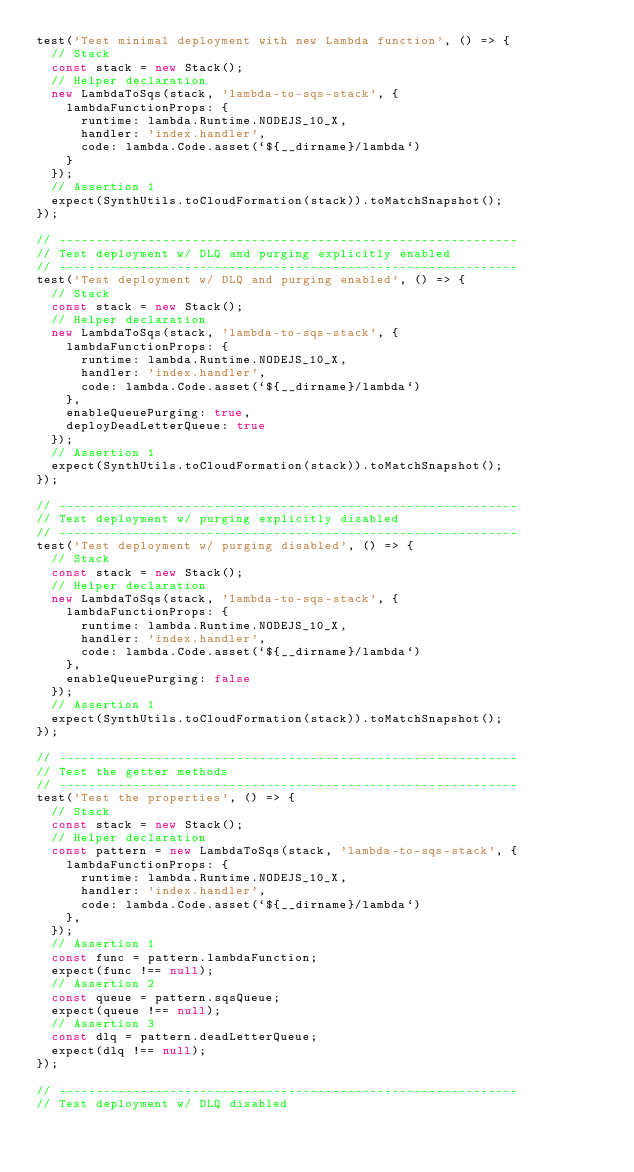Convert code to text. <code><loc_0><loc_0><loc_500><loc_500><_TypeScript_>test('Test minimal deployment with new Lambda function', () => {
  // Stack
  const stack = new Stack();
  // Helper declaration
  new LambdaToSqs(stack, 'lambda-to-sqs-stack', {
    lambdaFunctionProps: {
      runtime: lambda.Runtime.NODEJS_10_X,
      handler: 'index.handler',
      code: lambda.Code.asset(`${__dirname}/lambda`)
    }
  });
  // Assertion 1
  expect(SynthUtils.toCloudFormation(stack)).toMatchSnapshot();
});

// --------------------------------------------------------------
// Test deployment w/ DLQ and purging explicitly enabled
// --------------------------------------------------------------
test('Test deployment w/ DLQ and purging enabled', () => {
  // Stack
  const stack = new Stack();
  // Helper declaration
  new LambdaToSqs(stack, 'lambda-to-sqs-stack', {
    lambdaFunctionProps: {
      runtime: lambda.Runtime.NODEJS_10_X,
      handler: 'index.handler',
      code: lambda.Code.asset(`${__dirname}/lambda`)
    },
    enableQueuePurging: true,
    deployDeadLetterQueue: true
  });
  // Assertion 1
  expect(SynthUtils.toCloudFormation(stack)).toMatchSnapshot();
});

// --------------------------------------------------------------
// Test deployment w/ purging explicitly disabled
// --------------------------------------------------------------
test('Test deployment w/ purging disabled', () => {
  // Stack
  const stack = new Stack();
  // Helper declaration
  new LambdaToSqs(stack, 'lambda-to-sqs-stack', {
    lambdaFunctionProps: {
      runtime: lambda.Runtime.NODEJS_10_X,
      handler: 'index.handler',
      code: lambda.Code.asset(`${__dirname}/lambda`)
    },
    enableQueuePurging: false
  });
  // Assertion 1
  expect(SynthUtils.toCloudFormation(stack)).toMatchSnapshot();
});

// --------------------------------------------------------------
// Test the getter methods
// --------------------------------------------------------------
test('Test the properties', () => {
  // Stack
  const stack = new Stack();
  // Helper declaration
  const pattern = new LambdaToSqs(stack, 'lambda-to-sqs-stack', {
    lambdaFunctionProps: {
      runtime: lambda.Runtime.NODEJS_10_X,
      handler: 'index.handler',
      code: lambda.Code.asset(`${__dirname}/lambda`)
    },
  });
  // Assertion 1
  const func = pattern.lambdaFunction;
  expect(func !== null);
  // Assertion 2
  const queue = pattern.sqsQueue;
  expect(queue !== null);
  // Assertion 3
  const dlq = pattern.deadLetterQueue;
  expect(dlq !== null);
});

// --------------------------------------------------------------
// Test deployment w/ DLQ disabled</code> 